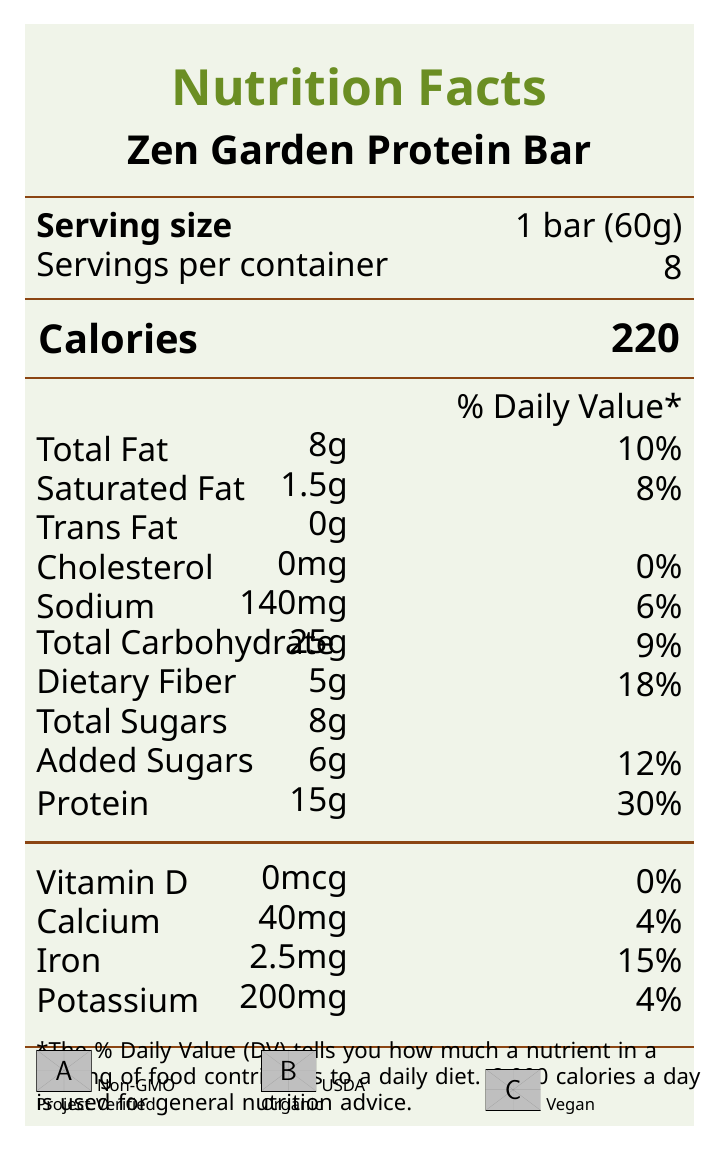what is the serving size of the Zen Garden Protein Bar? The serving size is listed as "1 bar (60g)" under the serving size information section.
Answer: 1 bar (60g) how many calories are in each serving of the Zen Garden Protein Bar? The calorie information shows that each serving contains 220 calories.
Answer: 220 what is the percentage daily value of protein in one bar? The daily value for protein is specified as 30% next to the protein amount of 15g.
Answer: 30% which vitamins and minerals have a 4% daily value in one serving? Both calcium (40mg) and potassium (200mg) have a 4% daily value listed in the vitamin and mineral table.
Answer: Calcium and Potassium is there any trans fat in the Zen Garden Protein Bar? The document lists 0g for Trans Fat, indicating there is no trans fat in the bar.
Answer: No what is the main protein source in the Zen Garden Protein Bar? These ingredients are listed first in the ingredients section, indicating they are the main sources of protein.
Answer: Pea protein isolate and Brown rice protein what is the total carbohydrate content per serving? A. 20g B. 25g C. 30g D. 18g The document shows a total carbohydrate amount of 25g.
Answer: B what is the flavor profile of the Zen Garden Protein Bar? A. Sweet and fruity B. Spicy and tangy C. Earthy and aromatic D. Nutty and savory The flavor profile is described as a blend of earthy kabocha squash, zesty daikon radish, aromatic shiso, and a hint of matcha green tea.
Answer: C is the product certified by the USDA for being organic? The USDA Organic certification is mentioned in the certifications section, and a corresponding logo is included in the document.
Answer: Yes provide a summary of the entire document related to the Zen Garden Protein Bar The document provides detailed nutritional information, ingredient list, certifications, and sustainability notes for the Zen Garden Protein Bar, highlighting its health benefits and environmentally friendly packaging.
Answer: The Zen Garden Protein Bar is a plant-based, vegan, non-GMO snack inspired by Japanese garden vegetables and Miyazaki films. Each serving size is 1 bar (60g) with 220 calories. It contains 15g of protein (30% DV), 8g total fat (10% DV), 25g carbohydrates (9% DV), and various vitamins and minerals. Ingredients include pea protein isolate, brown rice protein, and organic matcha green tea powder among others. The bar also carries several certifications such as Non-GMO Project Verified, USDA Organic, and Vegan. The sustainability of the product is emphasized with 100% compostable materials for the wrapper. what is the amount of added sugars per serving? The document states that there are 6g of added sugars per serving.
Answer: 6g which of the following minerals has the highest daily value percentage in the bar? 1. Calcium 2. Iron 3. Potassium Iron has a daily value of 15% which is higher than calcium (4%) and potassium (4%).
Answer: 2. Iron is there any cholesterol in the Zen Garden Protein Bar? The document lists 0mg for Cholesterol, indicating there is no cholesterol in the bar.
Answer: No does the document mention any specific dietary restrictions that the bar adheres to? The bar is mentioned to be vegan, as indicated in the certifications section.
Answer: Yes where is the Zen Garden Protein Bar manufactured? The document does not contain any visual information about the manufacturing location of the Zen Garden Protein Bar.
Answer: Not enough information 